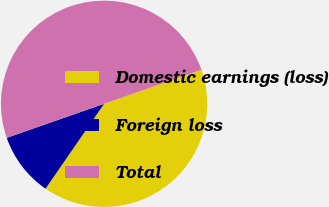Convert chart. <chart><loc_0><loc_0><loc_500><loc_500><pie_chart><fcel>Domestic earnings (loss)<fcel>Foreign loss<fcel>Total<nl><fcel>39.96%<fcel>10.04%<fcel>50.0%<nl></chart> 